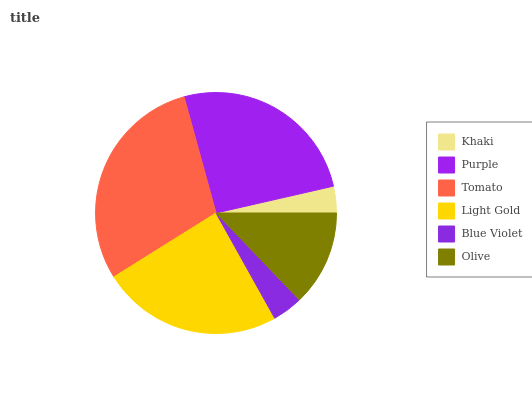Is Khaki the minimum?
Answer yes or no. Yes. Is Tomato the maximum?
Answer yes or no. Yes. Is Purple the minimum?
Answer yes or no. No. Is Purple the maximum?
Answer yes or no. No. Is Purple greater than Khaki?
Answer yes or no. Yes. Is Khaki less than Purple?
Answer yes or no. Yes. Is Khaki greater than Purple?
Answer yes or no. No. Is Purple less than Khaki?
Answer yes or no. No. Is Light Gold the high median?
Answer yes or no. Yes. Is Olive the low median?
Answer yes or no. Yes. Is Khaki the high median?
Answer yes or no. No. Is Light Gold the low median?
Answer yes or no. No. 